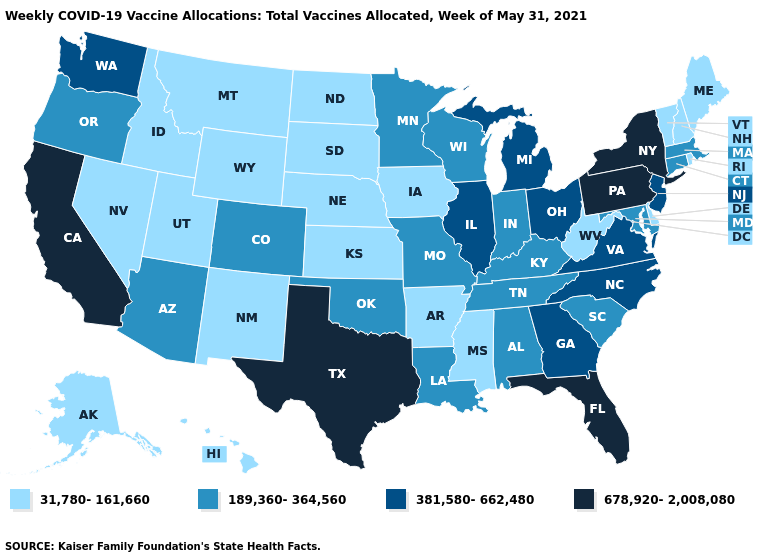What is the value of Mississippi?
Give a very brief answer. 31,780-161,660. Name the states that have a value in the range 678,920-2,008,080?
Keep it brief. California, Florida, New York, Pennsylvania, Texas. What is the highest value in states that border Nebraska?
Keep it brief. 189,360-364,560. Which states have the lowest value in the South?
Be succinct. Arkansas, Delaware, Mississippi, West Virginia. What is the value of Illinois?
Write a very short answer. 381,580-662,480. What is the value of Kentucky?
Answer briefly. 189,360-364,560. Which states have the lowest value in the MidWest?
Concise answer only. Iowa, Kansas, Nebraska, North Dakota, South Dakota. Which states hav the highest value in the MidWest?
Be succinct. Illinois, Michigan, Ohio. Name the states that have a value in the range 189,360-364,560?
Answer briefly. Alabama, Arizona, Colorado, Connecticut, Indiana, Kentucky, Louisiana, Maryland, Massachusetts, Minnesota, Missouri, Oklahoma, Oregon, South Carolina, Tennessee, Wisconsin. What is the lowest value in the MidWest?
Keep it brief. 31,780-161,660. Name the states that have a value in the range 381,580-662,480?
Write a very short answer. Georgia, Illinois, Michigan, New Jersey, North Carolina, Ohio, Virginia, Washington. Name the states that have a value in the range 189,360-364,560?
Be succinct. Alabama, Arizona, Colorado, Connecticut, Indiana, Kentucky, Louisiana, Maryland, Massachusetts, Minnesota, Missouri, Oklahoma, Oregon, South Carolina, Tennessee, Wisconsin. What is the value of Kentucky?
Quick response, please. 189,360-364,560. Does the first symbol in the legend represent the smallest category?
Be succinct. Yes. 